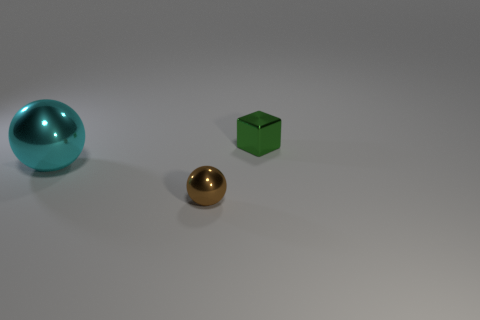Add 2 big cyan metal balls. How many objects exist? 5 Subtract all blocks. How many objects are left? 2 Add 1 tiny brown objects. How many tiny brown objects are left? 2 Add 3 metal spheres. How many metal spheres exist? 5 Subtract 1 cyan balls. How many objects are left? 2 Subtract all small spheres. Subtract all brown metallic objects. How many objects are left? 1 